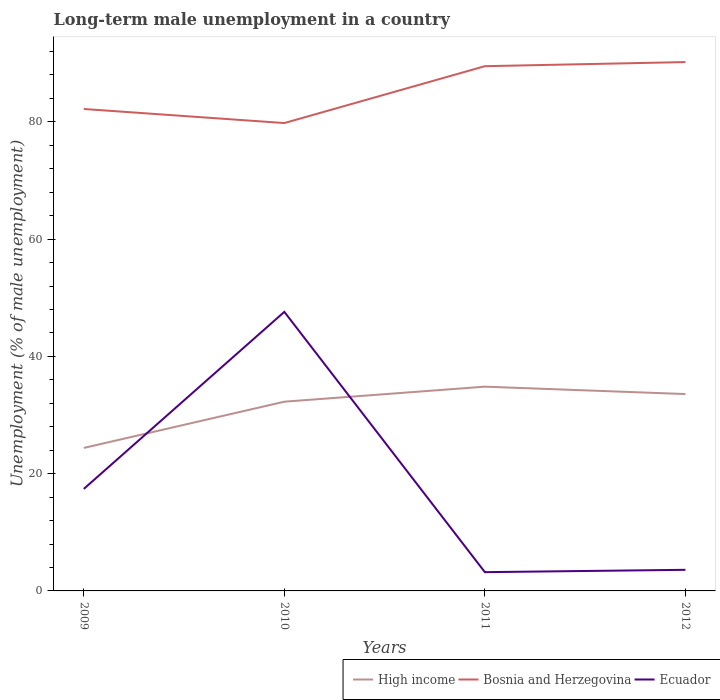How many different coloured lines are there?
Provide a short and direct response. 3. Does the line corresponding to High income intersect with the line corresponding to Bosnia and Herzegovina?
Give a very brief answer. No. Is the number of lines equal to the number of legend labels?
Provide a short and direct response. Yes. Across all years, what is the maximum percentage of long-term unemployed male population in Ecuador?
Your response must be concise. 3.2. What is the total percentage of long-term unemployed male population in High income in the graph?
Your answer should be compact. -7.89. What is the difference between the highest and the second highest percentage of long-term unemployed male population in Ecuador?
Give a very brief answer. 44.4. What is the difference between the highest and the lowest percentage of long-term unemployed male population in Bosnia and Herzegovina?
Give a very brief answer. 2. How many lines are there?
Keep it short and to the point. 3. What is the difference between two consecutive major ticks on the Y-axis?
Keep it short and to the point. 20. Does the graph contain any zero values?
Make the answer very short. No. Does the graph contain grids?
Your response must be concise. No. Where does the legend appear in the graph?
Make the answer very short. Bottom right. How many legend labels are there?
Offer a terse response. 3. What is the title of the graph?
Offer a very short reply. Long-term male unemployment in a country. What is the label or title of the X-axis?
Ensure brevity in your answer.  Years. What is the label or title of the Y-axis?
Ensure brevity in your answer.  Unemployment (% of male unemployment). What is the Unemployment (% of male unemployment) in High income in 2009?
Your answer should be very brief. 24.39. What is the Unemployment (% of male unemployment) of Bosnia and Herzegovina in 2009?
Your answer should be compact. 82.2. What is the Unemployment (% of male unemployment) in Ecuador in 2009?
Ensure brevity in your answer.  17.4. What is the Unemployment (% of male unemployment) of High income in 2010?
Offer a terse response. 32.28. What is the Unemployment (% of male unemployment) of Bosnia and Herzegovina in 2010?
Your answer should be very brief. 79.8. What is the Unemployment (% of male unemployment) of Ecuador in 2010?
Your answer should be very brief. 47.6. What is the Unemployment (% of male unemployment) in High income in 2011?
Your answer should be compact. 34.84. What is the Unemployment (% of male unemployment) of Bosnia and Herzegovina in 2011?
Offer a terse response. 89.5. What is the Unemployment (% of male unemployment) of Ecuador in 2011?
Provide a succinct answer. 3.2. What is the Unemployment (% of male unemployment) in High income in 2012?
Your answer should be compact. 33.58. What is the Unemployment (% of male unemployment) in Bosnia and Herzegovina in 2012?
Make the answer very short. 90.2. What is the Unemployment (% of male unemployment) of Ecuador in 2012?
Provide a short and direct response. 3.6. Across all years, what is the maximum Unemployment (% of male unemployment) of High income?
Make the answer very short. 34.84. Across all years, what is the maximum Unemployment (% of male unemployment) in Bosnia and Herzegovina?
Your answer should be compact. 90.2. Across all years, what is the maximum Unemployment (% of male unemployment) of Ecuador?
Your answer should be compact. 47.6. Across all years, what is the minimum Unemployment (% of male unemployment) of High income?
Provide a short and direct response. 24.39. Across all years, what is the minimum Unemployment (% of male unemployment) of Bosnia and Herzegovina?
Provide a short and direct response. 79.8. Across all years, what is the minimum Unemployment (% of male unemployment) of Ecuador?
Provide a short and direct response. 3.2. What is the total Unemployment (% of male unemployment) in High income in the graph?
Your answer should be very brief. 125.08. What is the total Unemployment (% of male unemployment) in Bosnia and Herzegovina in the graph?
Provide a succinct answer. 341.7. What is the total Unemployment (% of male unemployment) of Ecuador in the graph?
Your response must be concise. 71.8. What is the difference between the Unemployment (% of male unemployment) of High income in 2009 and that in 2010?
Offer a very short reply. -7.89. What is the difference between the Unemployment (% of male unemployment) in Bosnia and Herzegovina in 2009 and that in 2010?
Provide a short and direct response. 2.4. What is the difference between the Unemployment (% of male unemployment) of Ecuador in 2009 and that in 2010?
Your response must be concise. -30.2. What is the difference between the Unemployment (% of male unemployment) in High income in 2009 and that in 2011?
Offer a very short reply. -10.45. What is the difference between the Unemployment (% of male unemployment) of Bosnia and Herzegovina in 2009 and that in 2011?
Ensure brevity in your answer.  -7.3. What is the difference between the Unemployment (% of male unemployment) in High income in 2009 and that in 2012?
Keep it short and to the point. -9.19. What is the difference between the Unemployment (% of male unemployment) of High income in 2010 and that in 2011?
Ensure brevity in your answer.  -2.56. What is the difference between the Unemployment (% of male unemployment) of Ecuador in 2010 and that in 2011?
Offer a very short reply. 44.4. What is the difference between the Unemployment (% of male unemployment) in High income in 2010 and that in 2012?
Your response must be concise. -1.3. What is the difference between the Unemployment (% of male unemployment) of High income in 2011 and that in 2012?
Your answer should be very brief. 1.26. What is the difference between the Unemployment (% of male unemployment) in Bosnia and Herzegovina in 2011 and that in 2012?
Your response must be concise. -0.7. What is the difference between the Unemployment (% of male unemployment) in Ecuador in 2011 and that in 2012?
Offer a very short reply. -0.4. What is the difference between the Unemployment (% of male unemployment) in High income in 2009 and the Unemployment (% of male unemployment) in Bosnia and Herzegovina in 2010?
Keep it short and to the point. -55.41. What is the difference between the Unemployment (% of male unemployment) of High income in 2009 and the Unemployment (% of male unemployment) of Ecuador in 2010?
Your response must be concise. -23.21. What is the difference between the Unemployment (% of male unemployment) of Bosnia and Herzegovina in 2009 and the Unemployment (% of male unemployment) of Ecuador in 2010?
Make the answer very short. 34.6. What is the difference between the Unemployment (% of male unemployment) in High income in 2009 and the Unemployment (% of male unemployment) in Bosnia and Herzegovina in 2011?
Provide a short and direct response. -65.11. What is the difference between the Unemployment (% of male unemployment) in High income in 2009 and the Unemployment (% of male unemployment) in Ecuador in 2011?
Your response must be concise. 21.19. What is the difference between the Unemployment (% of male unemployment) in Bosnia and Herzegovina in 2009 and the Unemployment (% of male unemployment) in Ecuador in 2011?
Provide a short and direct response. 79. What is the difference between the Unemployment (% of male unemployment) in High income in 2009 and the Unemployment (% of male unemployment) in Bosnia and Herzegovina in 2012?
Offer a terse response. -65.81. What is the difference between the Unemployment (% of male unemployment) of High income in 2009 and the Unemployment (% of male unemployment) of Ecuador in 2012?
Your answer should be very brief. 20.79. What is the difference between the Unemployment (% of male unemployment) in Bosnia and Herzegovina in 2009 and the Unemployment (% of male unemployment) in Ecuador in 2012?
Your response must be concise. 78.6. What is the difference between the Unemployment (% of male unemployment) of High income in 2010 and the Unemployment (% of male unemployment) of Bosnia and Herzegovina in 2011?
Offer a very short reply. -57.22. What is the difference between the Unemployment (% of male unemployment) in High income in 2010 and the Unemployment (% of male unemployment) in Ecuador in 2011?
Provide a short and direct response. 29.08. What is the difference between the Unemployment (% of male unemployment) in Bosnia and Herzegovina in 2010 and the Unemployment (% of male unemployment) in Ecuador in 2011?
Your answer should be compact. 76.6. What is the difference between the Unemployment (% of male unemployment) in High income in 2010 and the Unemployment (% of male unemployment) in Bosnia and Herzegovina in 2012?
Your answer should be very brief. -57.92. What is the difference between the Unemployment (% of male unemployment) in High income in 2010 and the Unemployment (% of male unemployment) in Ecuador in 2012?
Make the answer very short. 28.68. What is the difference between the Unemployment (% of male unemployment) in Bosnia and Herzegovina in 2010 and the Unemployment (% of male unemployment) in Ecuador in 2012?
Your answer should be very brief. 76.2. What is the difference between the Unemployment (% of male unemployment) of High income in 2011 and the Unemployment (% of male unemployment) of Bosnia and Herzegovina in 2012?
Provide a short and direct response. -55.36. What is the difference between the Unemployment (% of male unemployment) in High income in 2011 and the Unemployment (% of male unemployment) in Ecuador in 2012?
Offer a very short reply. 31.24. What is the difference between the Unemployment (% of male unemployment) of Bosnia and Herzegovina in 2011 and the Unemployment (% of male unemployment) of Ecuador in 2012?
Your answer should be compact. 85.9. What is the average Unemployment (% of male unemployment) of High income per year?
Provide a short and direct response. 31.27. What is the average Unemployment (% of male unemployment) of Bosnia and Herzegovina per year?
Your response must be concise. 85.42. What is the average Unemployment (% of male unemployment) of Ecuador per year?
Give a very brief answer. 17.95. In the year 2009, what is the difference between the Unemployment (% of male unemployment) of High income and Unemployment (% of male unemployment) of Bosnia and Herzegovina?
Your response must be concise. -57.81. In the year 2009, what is the difference between the Unemployment (% of male unemployment) of High income and Unemployment (% of male unemployment) of Ecuador?
Your response must be concise. 6.99. In the year 2009, what is the difference between the Unemployment (% of male unemployment) in Bosnia and Herzegovina and Unemployment (% of male unemployment) in Ecuador?
Keep it short and to the point. 64.8. In the year 2010, what is the difference between the Unemployment (% of male unemployment) of High income and Unemployment (% of male unemployment) of Bosnia and Herzegovina?
Offer a terse response. -47.52. In the year 2010, what is the difference between the Unemployment (% of male unemployment) in High income and Unemployment (% of male unemployment) in Ecuador?
Your answer should be compact. -15.32. In the year 2010, what is the difference between the Unemployment (% of male unemployment) of Bosnia and Herzegovina and Unemployment (% of male unemployment) of Ecuador?
Ensure brevity in your answer.  32.2. In the year 2011, what is the difference between the Unemployment (% of male unemployment) of High income and Unemployment (% of male unemployment) of Bosnia and Herzegovina?
Offer a very short reply. -54.66. In the year 2011, what is the difference between the Unemployment (% of male unemployment) of High income and Unemployment (% of male unemployment) of Ecuador?
Offer a terse response. 31.64. In the year 2011, what is the difference between the Unemployment (% of male unemployment) of Bosnia and Herzegovina and Unemployment (% of male unemployment) of Ecuador?
Offer a terse response. 86.3. In the year 2012, what is the difference between the Unemployment (% of male unemployment) of High income and Unemployment (% of male unemployment) of Bosnia and Herzegovina?
Your answer should be very brief. -56.62. In the year 2012, what is the difference between the Unemployment (% of male unemployment) in High income and Unemployment (% of male unemployment) in Ecuador?
Your response must be concise. 29.98. In the year 2012, what is the difference between the Unemployment (% of male unemployment) of Bosnia and Herzegovina and Unemployment (% of male unemployment) of Ecuador?
Offer a very short reply. 86.6. What is the ratio of the Unemployment (% of male unemployment) of High income in 2009 to that in 2010?
Your answer should be very brief. 0.76. What is the ratio of the Unemployment (% of male unemployment) of Bosnia and Herzegovina in 2009 to that in 2010?
Your answer should be compact. 1.03. What is the ratio of the Unemployment (% of male unemployment) in Ecuador in 2009 to that in 2010?
Offer a very short reply. 0.37. What is the ratio of the Unemployment (% of male unemployment) of High income in 2009 to that in 2011?
Ensure brevity in your answer.  0.7. What is the ratio of the Unemployment (% of male unemployment) of Bosnia and Herzegovina in 2009 to that in 2011?
Offer a very short reply. 0.92. What is the ratio of the Unemployment (% of male unemployment) of Ecuador in 2009 to that in 2011?
Provide a succinct answer. 5.44. What is the ratio of the Unemployment (% of male unemployment) in High income in 2009 to that in 2012?
Offer a very short reply. 0.73. What is the ratio of the Unemployment (% of male unemployment) of Bosnia and Herzegovina in 2009 to that in 2012?
Offer a terse response. 0.91. What is the ratio of the Unemployment (% of male unemployment) of Ecuador in 2009 to that in 2012?
Your response must be concise. 4.83. What is the ratio of the Unemployment (% of male unemployment) of High income in 2010 to that in 2011?
Offer a terse response. 0.93. What is the ratio of the Unemployment (% of male unemployment) in Bosnia and Herzegovina in 2010 to that in 2011?
Make the answer very short. 0.89. What is the ratio of the Unemployment (% of male unemployment) of Ecuador in 2010 to that in 2011?
Offer a terse response. 14.88. What is the ratio of the Unemployment (% of male unemployment) of High income in 2010 to that in 2012?
Offer a terse response. 0.96. What is the ratio of the Unemployment (% of male unemployment) in Bosnia and Herzegovina in 2010 to that in 2012?
Make the answer very short. 0.88. What is the ratio of the Unemployment (% of male unemployment) of Ecuador in 2010 to that in 2012?
Provide a succinct answer. 13.22. What is the ratio of the Unemployment (% of male unemployment) in High income in 2011 to that in 2012?
Offer a terse response. 1.04. What is the ratio of the Unemployment (% of male unemployment) of Ecuador in 2011 to that in 2012?
Give a very brief answer. 0.89. What is the difference between the highest and the second highest Unemployment (% of male unemployment) in High income?
Make the answer very short. 1.26. What is the difference between the highest and the second highest Unemployment (% of male unemployment) of Ecuador?
Make the answer very short. 30.2. What is the difference between the highest and the lowest Unemployment (% of male unemployment) of High income?
Your answer should be compact. 10.45. What is the difference between the highest and the lowest Unemployment (% of male unemployment) in Ecuador?
Give a very brief answer. 44.4. 